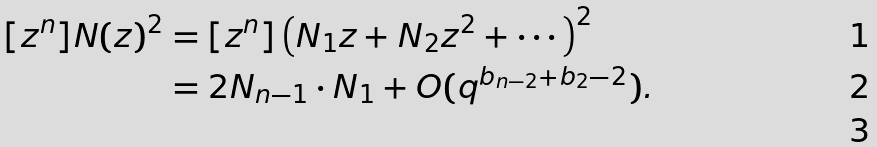<formula> <loc_0><loc_0><loc_500><loc_500>[ z ^ { n } ] N ( z ) ^ { 2 } & = [ z ^ { n } ] \left ( N _ { 1 } z + N _ { 2 } z ^ { 2 } + \cdots \right ) ^ { 2 } \\ & = 2 N _ { n - 1 } \cdot N _ { 1 } + O ( q ^ { b _ { n - 2 } + b _ { 2 } - 2 } ) . \\</formula> 